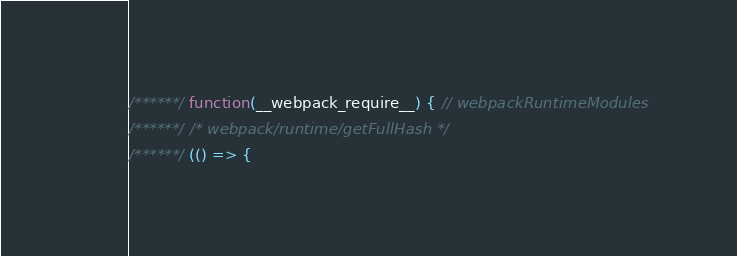Convert code to text. <code><loc_0><loc_0><loc_500><loc_500><_JavaScript_>/******/ function(__webpack_require__) { // webpackRuntimeModules
/******/ /* webpack/runtime/getFullHash */
/******/ (() => {</code> 